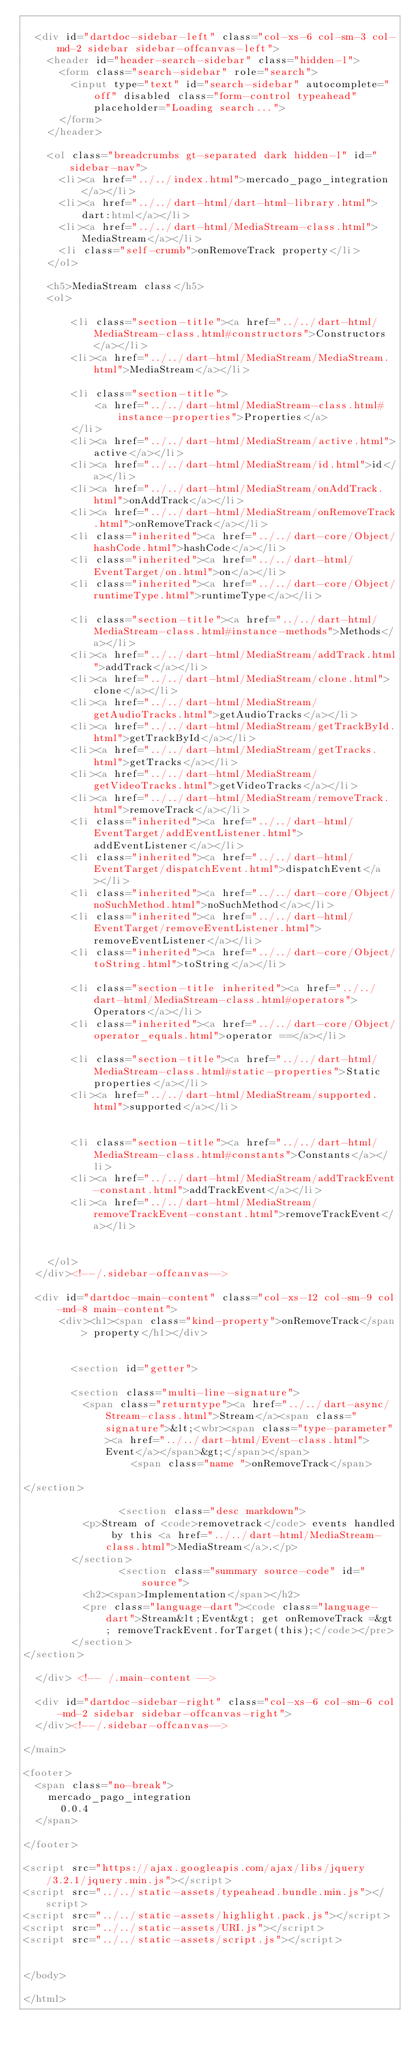<code> <loc_0><loc_0><loc_500><loc_500><_HTML_>
  <div id="dartdoc-sidebar-left" class="col-xs-6 col-sm-3 col-md-2 sidebar sidebar-offcanvas-left">
    <header id="header-search-sidebar" class="hidden-l">
      <form class="search-sidebar" role="search">
        <input type="text" id="search-sidebar" autocomplete="off" disabled class="form-control typeahead" placeholder="Loading search...">
      </form>
    </header>
    
    <ol class="breadcrumbs gt-separated dark hidden-l" id="sidebar-nav">
      <li><a href="../../index.html">mercado_pago_integration</a></li>
      <li><a href="../../dart-html/dart-html-library.html">dart:html</a></li>
      <li><a href="../../dart-html/MediaStream-class.html">MediaStream</a></li>
      <li class="self-crumb">onRemoveTrack property</li>
    </ol>
    
    <h5>MediaStream class</h5>
    <ol>
    
        <li class="section-title"><a href="../../dart-html/MediaStream-class.html#constructors">Constructors</a></li>
        <li><a href="../../dart-html/MediaStream/MediaStream.html">MediaStream</a></li>
    
        <li class="section-title">
            <a href="../../dart-html/MediaStream-class.html#instance-properties">Properties</a>
        </li>
        <li><a href="../../dart-html/MediaStream/active.html">active</a></li>
        <li><a href="../../dart-html/MediaStream/id.html">id</a></li>
        <li><a href="../../dart-html/MediaStream/onAddTrack.html">onAddTrack</a></li>
        <li><a href="../../dart-html/MediaStream/onRemoveTrack.html">onRemoveTrack</a></li>
        <li class="inherited"><a href="../../dart-core/Object/hashCode.html">hashCode</a></li>
        <li class="inherited"><a href="../../dart-html/EventTarget/on.html">on</a></li>
        <li class="inherited"><a href="../../dart-core/Object/runtimeType.html">runtimeType</a></li>
    
        <li class="section-title"><a href="../../dart-html/MediaStream-class.html#instance-methods">Methods</a></li>
        <li><a href="../../dart-html/MediaStream/addTrack.html">addTrack</a></li>
        <li><a href="../../dart-html/MediaStream/clone.html">clone</a></li>
        <li><a href="../../dart-html/MediaStream/getAudioTracks.html">getAudioTracks</a></li>
        <li><a href="../../dart-html/MediaStream/getTrackById.html">getTrackById</a></li>
        <li><a href="../../dart-html/MediaStream/getTracks.html">getTracks</a></li>
        <li><a href="../../dart-html/MediaStream/getVideoTracks.html">getVideoTracks</a></li>
        <li><a href="../../dart-html/MediaStream/removeTrack.html">removeTrack</a></li>
        <li class="inherited"><a href="../../dart-html/EventTarget/addEventListener.html">addEventListener</a></li>
        <li class="inherited"><a href="../../dart-html/EventTarget/dispatchEvent.html">dispatchEvent</a></li>
        <li class="inherited"><a href="../../dart-core/Object/noSuchMethod.html">noSuchMethod</a></li>
        <li class="inherited"><a href="../../dart-html/EventTarget/removeEventListener.html">removeEventListener</a></li>
        <li class="inherited"><a href="../../dart-core/Object/toString.html">toString</a></li>
    
        <li class="section-title inherited"><a href="../../dart-html/MediaStream-class.html#operators">Operators</a></li>
        <li class="inherited"><a href="../../dart-core/Object/operator_equals.html">operator ==</a></li>
    
        <li class="section-title"><a href="../../dart-html/MediaStream-class.html#static-properties">Static properties</a></li>
        <li><a href="../../dart-html/MediaStream/supported.html">supported</a></li>
    
    
        <li class="section-title"><a href="../../dart-html/MediaStream-class.html#constants">Constants</a></li>
        <li><a href="../../dart-html/MediaStream/addTrackEvent-constant.html">addTrackEvent</a></li>
        <li><a href="../../dart-html/MediaStream/removeTrackEvent-constant.html">removeTrackEvent</a></li>
    
    
    </ol>
  </div><!--/.sidebar-offcanvas-->

  <div id="dartdoc-main-content" class="col-xs-12 col-sm-9 col-md-8 main-content">
      <div><h1><span class="kind-property">onRemoveTrack</span> property</h1></div>


        <section id="getter">
        
        <section class="multi-line-signature">
          <span class="returntype"><a href="../../dart-async/Stream-class.html">Stream</a><span class="signature">&lt;<wbr><span class="type-parameter"><a href="../../dart-html/Event-class.html">Event</a></span>&gt;</span></span>
                  <span class="name ">onRemoveTrack</span>
          
</section>
        
                <section class="desc markdown">
          <p>Stream of <code>removetrack</code> events handled by this <a href="../../dart-html/MediaStream-class.html">MediaStream</a>.</p>
        </section>
                <section class="summary source-code" id="source">
          <h2><span>Implementation</span></h2>
          <pre class="language-dart"><code class="language-dart">Stream&lt;Event&gt; get onRemoveTrack =&gt; removeTrackEvent.forTarget(this);</code></pre>
        </section>
</section>
        
  </div> <!-- /.main-content -->

  <div id="dartdoc-sidebar-right" class="col-xs-6 col-sm-6 col-md-2 sidebar sidebar-offcanvas-right">
  </div><!--/.sidebar-offcanvas-->

</main>

<footer>
  <span class="no-break">
    mercado_pago_integration
      0.0.4
  </span>

</footer>

<script src="https://ajax.googleapis.com/ajax/libs/jquery/3.2.1/jquery.min.js"></script>
<script src="../../static-assets/typeahead.bundle.min.js"></script>
<script src="../../static-assets/highlight.pack.js"></script>
<script src="../../static-assets/URI.js"></script>
<script src="../../static-assets/script.js"></script>


</body>

</html>
</code> 